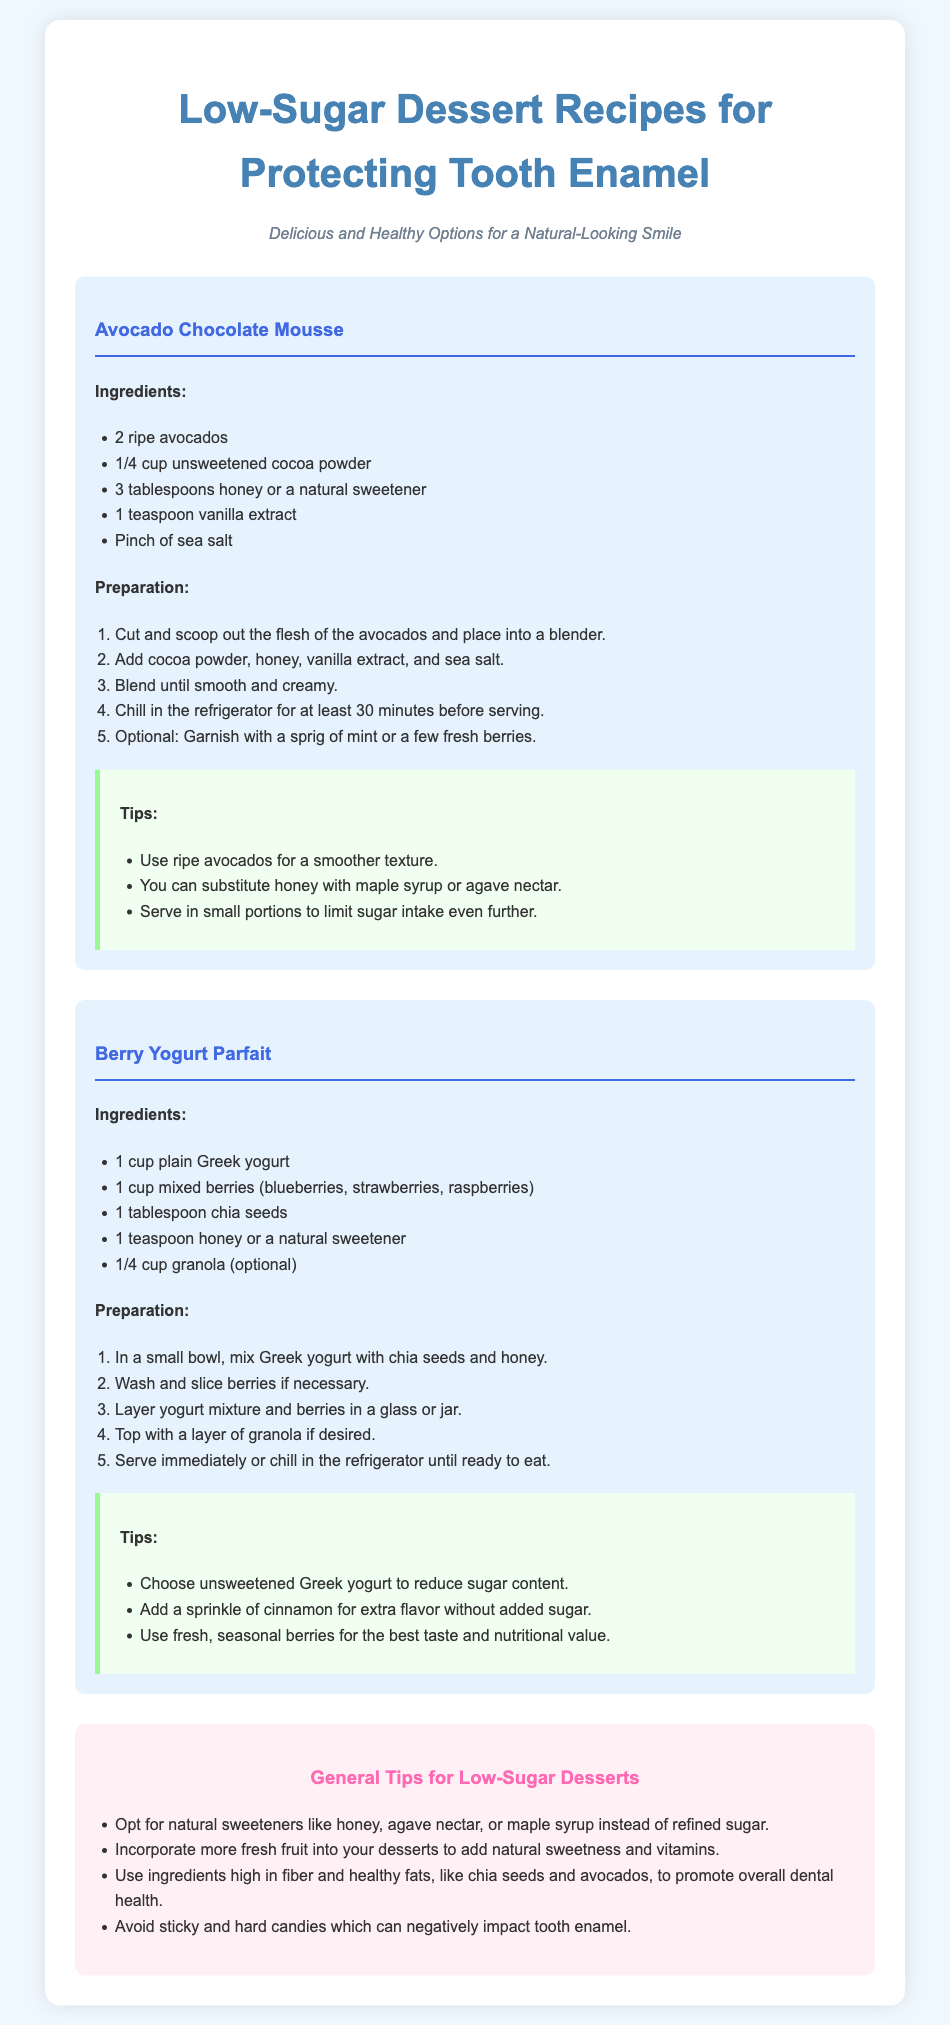What is one ingredient in the Avocado Chocolate Mousse? The ingredient list for the Avocado Chocolate Mousse includes avocados, cocoa powder, honey, vanilla extract, and sea salt.
Answer: avocados How long should you chill the Avocado Chocolate Mousse? The preparation steps indicate that the mousse should be chilled in the refrigerator for at least 30 minutes before serving.
Answer: 30 minutes What type of yogurt is used in the Berry Yogurt Parfait? The ingredients for the Berry Yogurt Parfait specify using plain Greek yogurt.
Answer: plain Greek yogurt How can you lower sugar consumption in the Berry Yogurt Parfait? The tips for the Berry Yogurt Parfait suggest choosing unsweetened Greek yogurt to reduce sugar content.
Answer: unsweetened Greek yogurt What is a general tip for making low-sugar desserts? The general tips suggest opting for natural sweeteners like honey, agave nectar, or maple syrup instead of refined sugar.
Answer: natural sweeteners What can you use to add flavor without added sugar? The tips recommend adding a sprinkle of cinnamon for extra flavor without added sugar.
Answer: cinnamon What is a recommended ingredient for promoting overall dental health? The general tips encourage using ingredients high in fiber and healthy fats, such as chia seeds and avocados, for promoting dental health.
Answer: chia seeds What is one optional ingredient for the Berry Yogurt Parfait? The ingredient list mentions granola as an optional component for the Berry Yogurt Parfait.
Answer: granola 